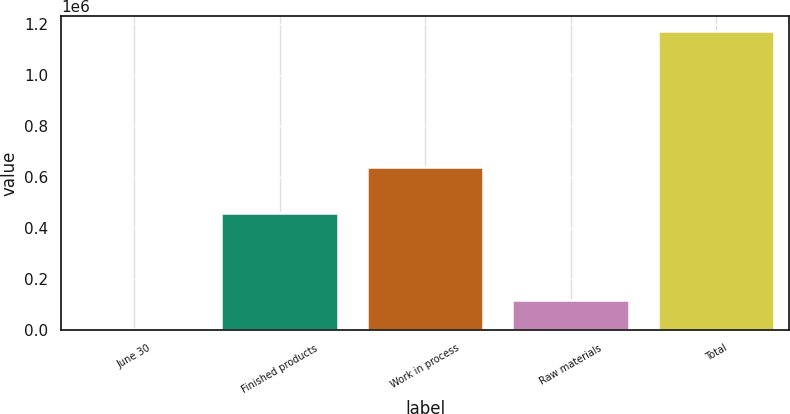Convert chart. <chart><loc_0><loc_0><loc_500><loc_500><bar_chart><fcel>June 30<fcel>Finished products<fcel>Work in process<fcel>Raw materials<fcel>Total<nl><fcel>2016<fcel>458657<fcel>639907<fcel>119147<fcel>1.17333e+06<nl></chart> 